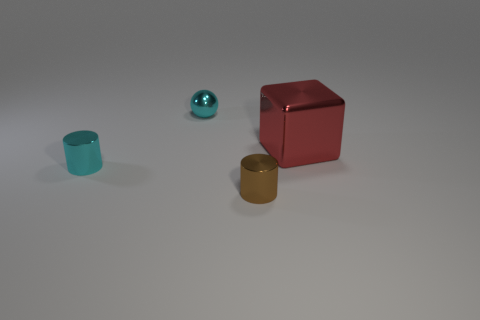There is a cyan metal object that is in front of the cyan thing behind the tiny cyan object in front of the large red thing; what size is it?
Give a very brief answer. Small. There is a brown metallic thing that is on the left side of the big red metal object; how big is it?
Give a very brief answer. Small. Is the color of the small metallic object behind the cyan metallic cylinder the same as the shiny cylinder that is behind the brown shiny object?
Provide a short and direct response. Yes. Are there any large blocks in front of the small cyan thing behind the large object?
Give a very brief answer. Yes. Is the number of tiny brown metallic cylinders to the right of the cyan sphere less than the number of things to the left of the brown cylinder?
Make the answer very short. Yes. Do the thing in front of the cyan metallic cylinder and the thing that is behind the big shiny object have the same material?
Offer a very short reply. Yes. How many big objects are either green things or shiny balls?
Give a very brief answer. 0. The other brown object that is the same material as the big object is what shape?
Make the answer very short. Cylinder. Is the number of brown metallic cylinders behind the tiny metal sphere less than the number of small cylinders?
Ensure brevity in your answer.  Yes. What number of metallic objects are tiny cyan cubes or large blocks?
Your answer should be very brief. 1. 